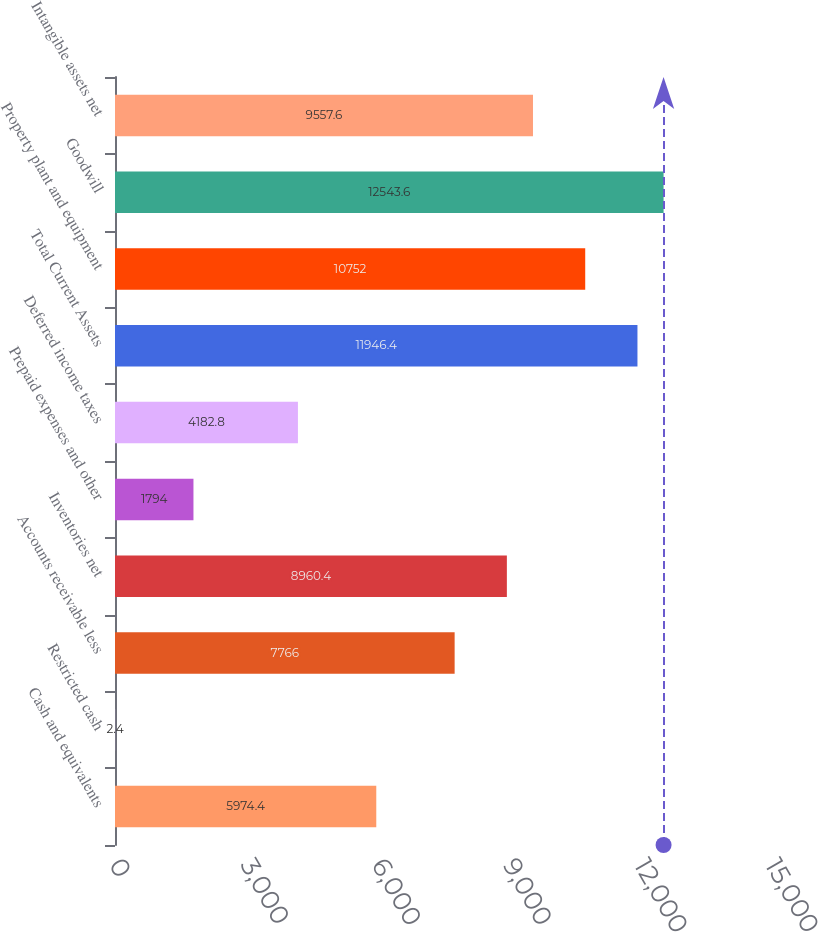Convert chart. <chart><loc_0><loc_0><loc_500><loc_500><bar_chart><fcel>Cash and equivalents<fcel>Restricted cash<fcel>Accounts receivable less<fcel>Inventories net<fcel>Prepaid expenses and other<fcel>Deferred income taxes<fcel>Total Current Assets<fcel>Property plant and equipment<fcel>Goodwill<fcel>Intangible assets net<nl><fcel>5974.4<fcel>2.4<fcel>7766<fcel>8960.4<fcel>1794<fcel>4182.8<fcel>11946.4<fcel>10752<fcel>12543.6<fcel>9557.6<nl></chart> 